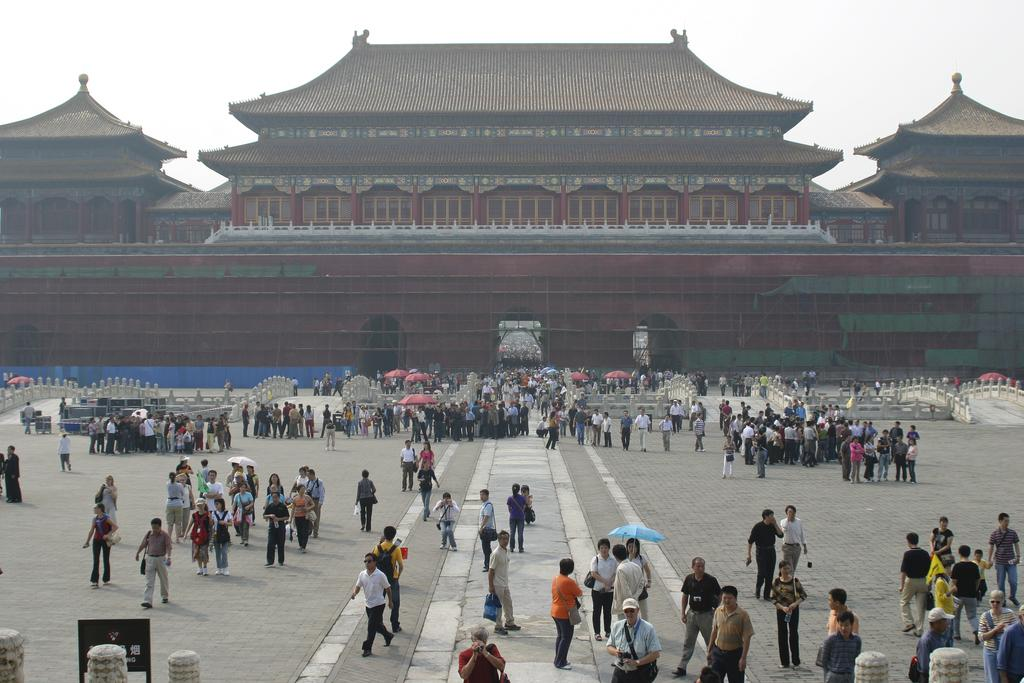What type of structures can be seen in the image? There are buildings in the image. Are there any people present in the image? Yes, there are people in the image. What objects are being used by the people in the image? Umbrellas are visible in the image. What type of barrier is present in the image? There is a fence in the image. What architectural feature is present in the image? There is a bridge in the image. What is visible in the background of the image? The sky is visible in the image. What type of sock is being used to clean the dirt off the buildings in the image? There is no sock or dirt present in the image; it features buildings, people, umbrellas, a fence, a bridge, and the sky. 